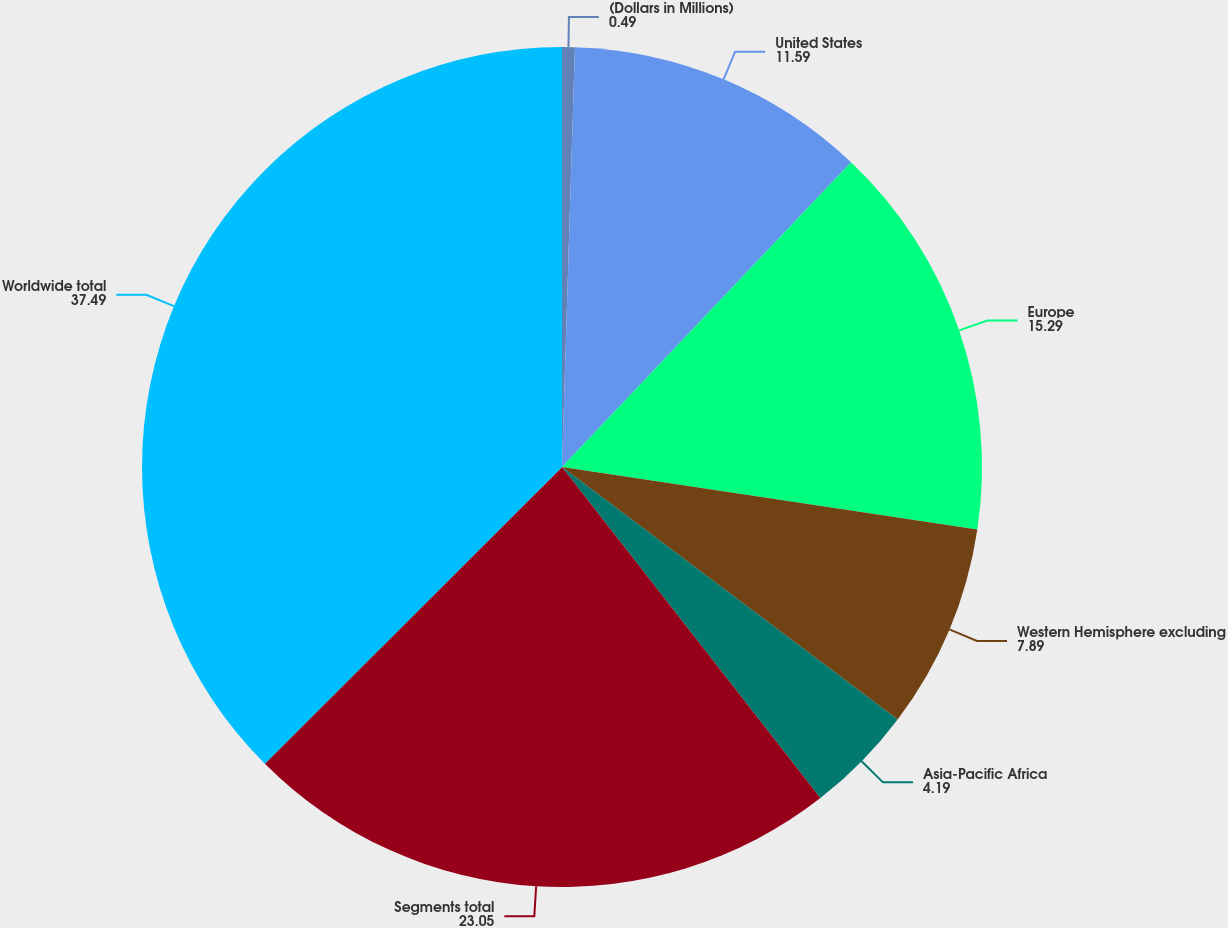Convert chart to OTSL. <chart><loc_0><loc_0><loc_500><loc_500><pie_chart><fcel>(Dollars in Millions)<fcel>United States<fcel>Europe<fcel>Western Hemisphere excluding<fcel>Asia-Pacific Africa<fcel>Segments total<fcel>Worldwide total<nl><fcel>0.49%<fcel>11.59%<fcel>15.29%<fcel>7.89%<fcel>4.19%<fcel>23.05%<fcel>37.49%<nl></chart> 